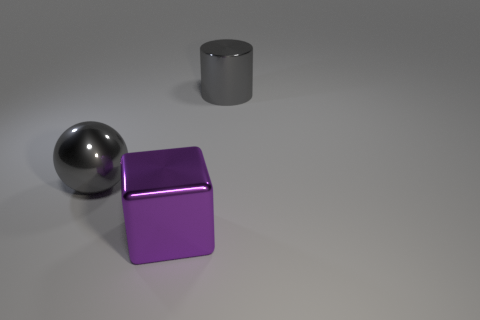What colors are present in this image? The image displays a variety of colors, namely gray for the cylinder and the sphere, purple for the cube, and the floor appears to be a neutral gray tone. What can the lighting in the scene tell us about the setting? The lighting appears to be soft and diffused, suggesting an indoor setting possibly within a studio environment designed for showcasing the objects without harsh shadows. 